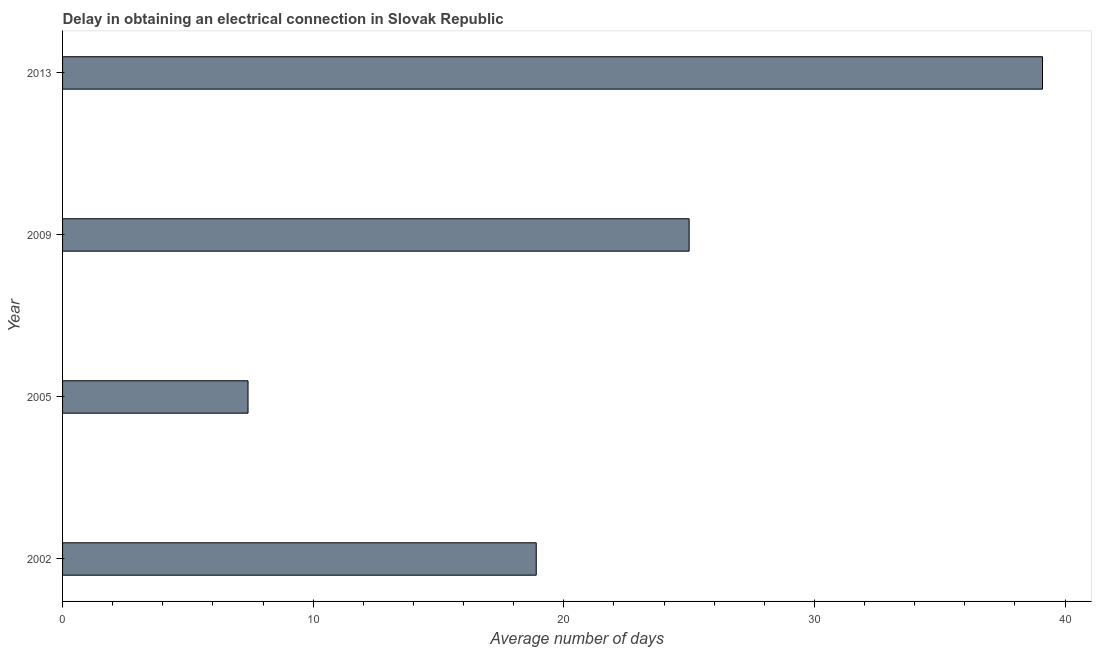Does the graph contain any zero values?
Offer a very short reply. No. Does the graph contain grids?
Offer a terse response. No. What is the title of the graph?
Keep it short and to the point. Delay in obtaining an electrical connection in Slovak Republic. What is the label or title of the X-axis?
Ensure brevity in your answer.  Average number of days. What is the dalay in electrical connection in 2009?
Offer a terse response. 25. Across all years, what is the maximum dalay in electrical connection?
Keep it short and to the point. 39.1. What is the sum of the dalay in electrical connection?
Your answer should be compact. 90.4. What is the difference between the dalay in electrical connection in 2002 and 2009?
Your answer should be compact. -6.1. What is the average dalay in electrical connection per year?
Offer a terse response. 22.6. What is the median dalay in electrical connection?
Your response must be concise. 21.95. What is the ratio of the dalay in electrical connection in 2009 to that in 2013?
Make the answer very short. 0.64. Is the difference between the dalay in electrical connection in 2005 and 2009 greater than the difference between any two years?
Ensure brevity in your answer.  No. What is the difference between the highest and the second highest dalay in electrical connection?
Keep it short and to the point. 14.1. What is the difference between the highest and the lowest dalay in electrical connection?
Provide a succinct answer. 31.7. Are all the bars in the graph horizontal?
Your answer should be very brief. Yes. What is the difference between two consecutive major ticks on the X-axis?
Offer a terse response. 10. What is the Average number of days in 2005?
Your response must be concise. 7.4. What is the Average number of days of 2013?
Ensure brevity in your answer.  39.1. What is the difference between the Average number of days in 2002 and 2009?
Give a very brief answer. -6.1. What is the difference between the Average number of days in 2002 and 2013?
Keep it short and to the point. -20.2. What is the difference between the Average number of days in 2005 and 2009?
Provide a short and direct response. -17.6. What is the difference between the Average number of days in 2005 and 2013?
Your answer should be compact. -31.7. What is the difference between the Average number of days in 2009 and 2013?
Offer a terse response. -14.1. What is the ratio of the Average number of days in 2002 to that in 2005?
Provide a succinct answer. 2.55. What is the ratio of the Average number of days in 2002 to that in 2009?
Make the answer very short. 0.76. What is the ratio of the Average number of days in 2002 to that in 2013?
Ensure brevity in your answer.  0.48. What is the ratio of the Average number of days in 2005 to that in 2009?
Make the answer very short. 0.3. What is the ratio of the Average number of days in 2005 to that in 2013?
Offer a terse response. 0.19. What is the ratio of the Average number of days in 2009 to that in 2013?
Ensure brevity in your answer.  0.64. 